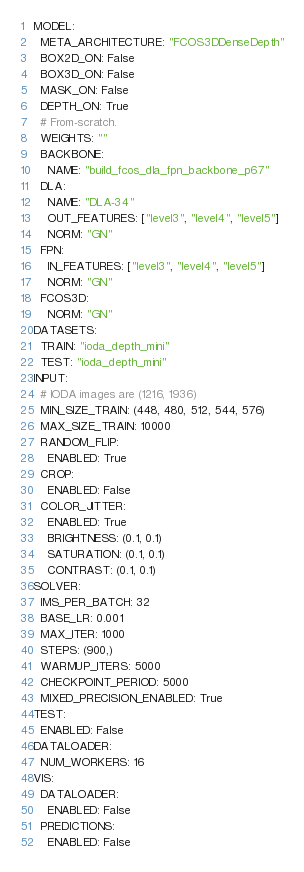<code> <loc_0><loc_0><loc_500><loc_500><_YAML_>MODEL:
  META_ARCHITECTURE: "FCOS3DDenseDepth"
  BOX2D_ON: False
  BOX3D_ON: False
  MASK_ON: False
  DEPTH_ON: True
  # From-scratch.
  WEIGHTS: ""
  BACKBONE:
    NAME: "build_fcos_dla_fpn_backbone_p67"
  DLA:
    NAME: "DLA-34"
    OUT_FEATURES: ["level3", "level4", "level5"]
    NORM: "GN"
  FPN:
    IN_FEATURES: ["level3", "level4", "level5"]
    NORM: "GN"
  FCOS3D:
    NORM: "GN"
DATASETS:
  TRAIN: "ioda_depth_mini"
  TEST: "ioda_depth_mini"
INPUT:
  # IODA images are (1216, 1936)
  MIN_SIZE_TRAIN: (448, 480, 512, 544, 576)
  MAX_SIZE_TRAIN: 10000
  RANDOM_FLIP:
    ENABLED: True
  CROP:
    ENABLED: False
  COLOR_JITTER:
    ENABLED: True
    BRIGHTNESS: (0.1, 0.1)
    SATURATION: (0.1, 0.1)
    CONTRAST: (0.1, 0.1)
SOLVER:
  IMS_PER_BATCH: 32
  BASE_LR: 0.001
  MAX_ITER: 1000
  STEPS: (900,)
  WARMUP_ITERS: 5000
  CHECKPOINT_PERIOD: 5000
  MIXED_PRECISION_ENABLED: True
TEST:
  ENABLED: False
DATALOADER:
  NUM_WORKERS: 16
VIS:
  DATALOADER:
    ENABLED: False
  PREDICTIONS:
    ENABLED: False
</code> 